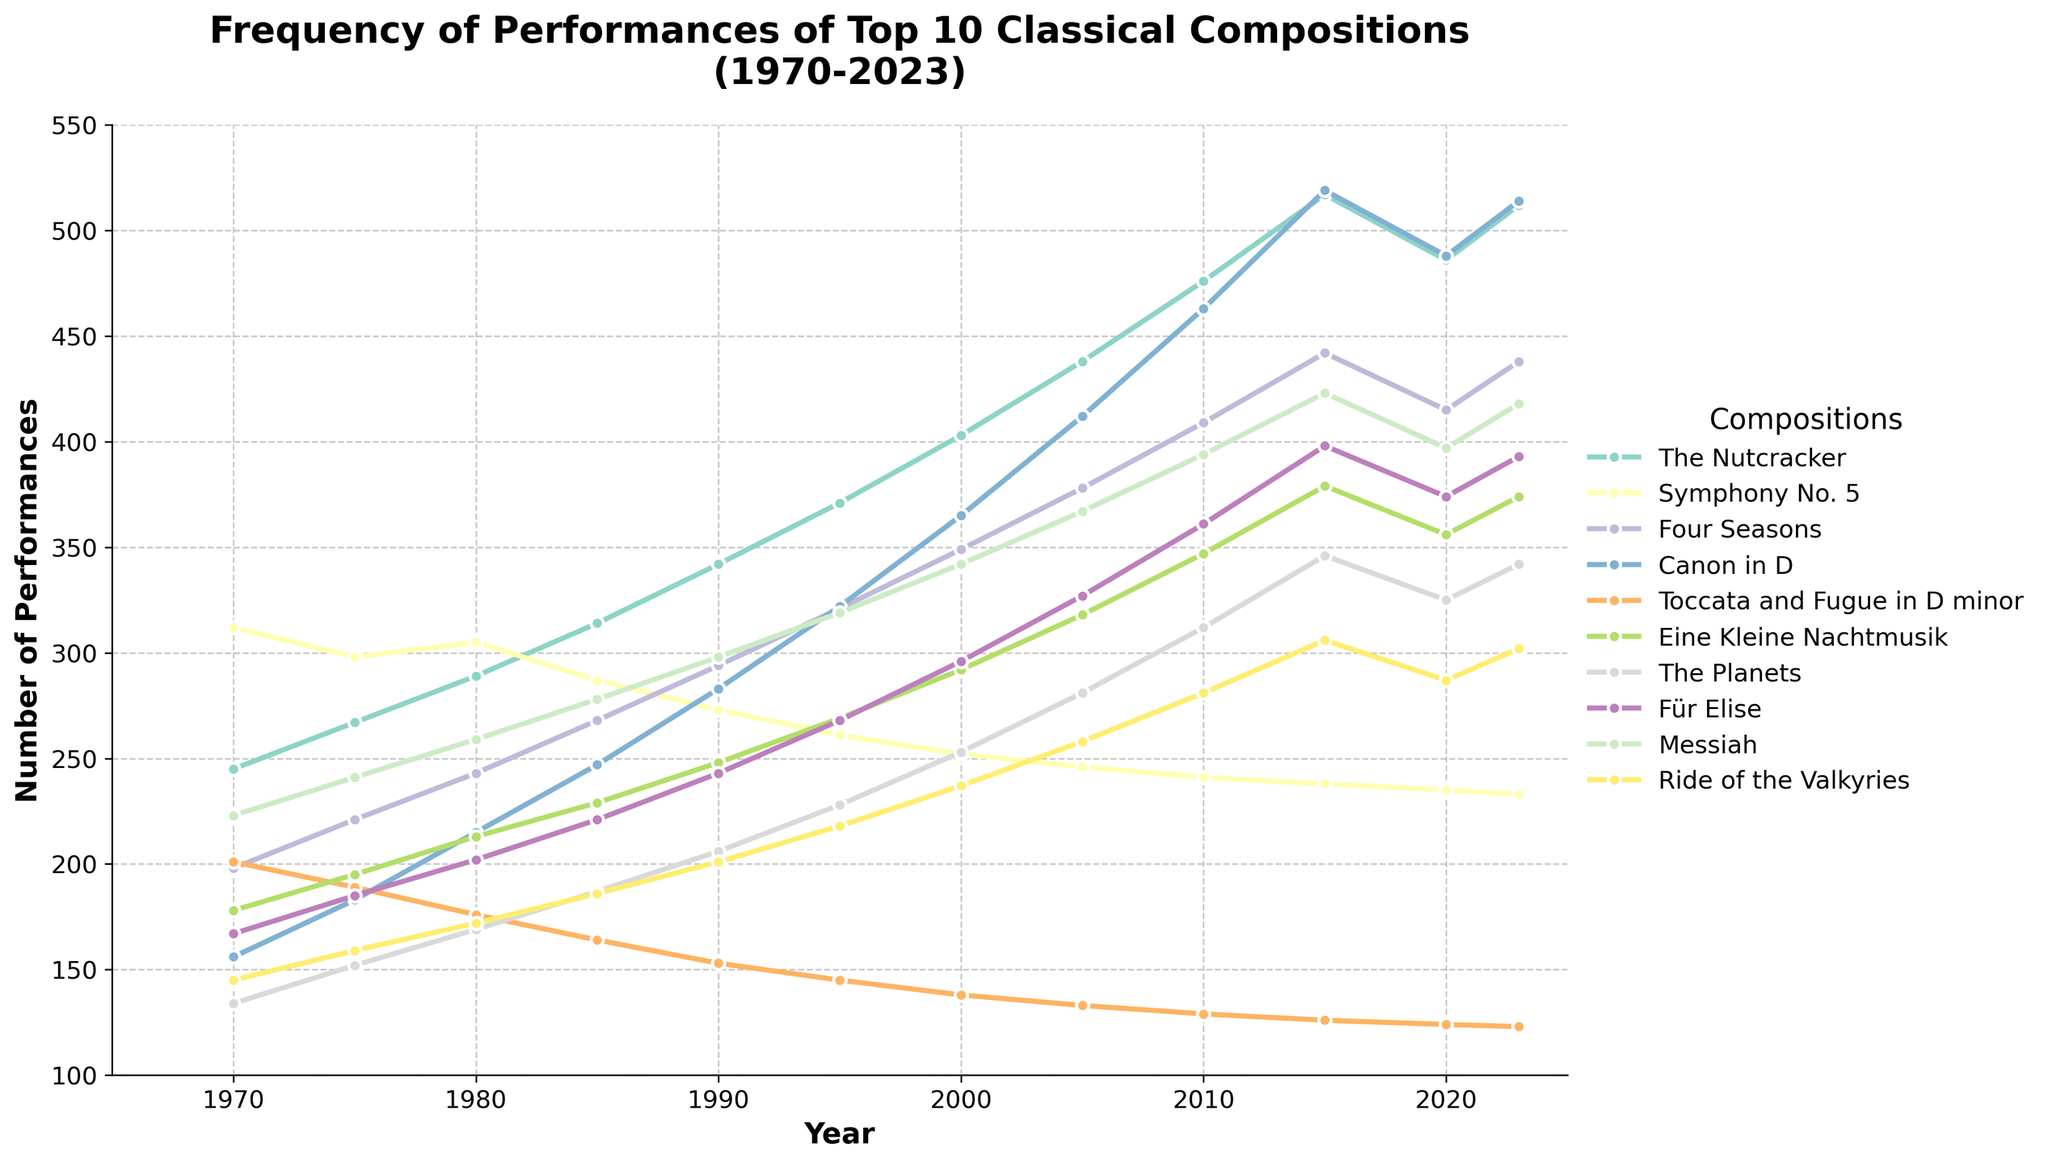What is the trend of performances for 'The Nutcracker' from 1970 to 2023? The line chart shows the performances of 'The Nutcracker' increasing from 245 performances in 1970 to 512 performances in 2023. The trend is steadily upward with some fluctuations around the years.
Answer: Increasing Which composition had the highest number of performances in 2023? By observing the highest point in 2023, 'The Nutcracker' had the highest number of performances with 512.
Answer: The Nutcracker By how much did 'Canon in D' performances increase from 1970 to 2023? In 1970, 'Canon in D' had 156 performances. By 2023, this increased to 514. The difference is 514 - 156 = 358.
Answer: 358 Which compositions had a decline in performances in 2020 compared to 2015? Looking at the downward trend between 2015 and 2020, 'The Nutcracker', 'Symphony No. 5', 'Four Seasons', and 'Messiah' show a decline in performances.
Answer: The Nutcracker, Symphony No. 5, Four Seasons, Messiah What is the average number of performances for 'The Planets' across all years shown in the chart? Add the performances of 'The Planets' across all years (134+152+169+187+206+228+253+281+312+346+325+342 = 2925) and divide by the number of data points (12). 2925/12 = 243.75
Answer: 243.75 By how many performances did 'Messiah' increase from 1975 to 2015? 'Messiah' had 241 performances in 1975 and 423 in 2015. The increase is 423 - 241 = 182.
Answer: 182 Which composition had consistent increases in performances every recorded year? Analyzing the slopes, 'Canon in D' shows a consistent increase across all years from 1970 to 2023.
Answer: Canon in D In 1980, which composition had the lowest number of performances and how many? In 1980, 'The Planets' had the lowest number of performances at 169.
Answer: The Planets, 169 Between 'Eine Kleine Nachtmusik' and 'Ride of the Valkyries', which had more performances in 2020? In 2020, 'Eine Kleine Nachtmusik' had 356 performances and 'Ride of the Valkyries' had 287. Therefore, 'Eine Kleine Nachtmusik' had more.
Answer: Eine Kleine Nachtmusik What is the range of performances for 'Symphony No. 5' from 1970 to 2023? Subtract the minimum number of performances (233 in 2023) from the maximum (312 in 1970). The range is 312 - 233 = 79.
Answer: 79 